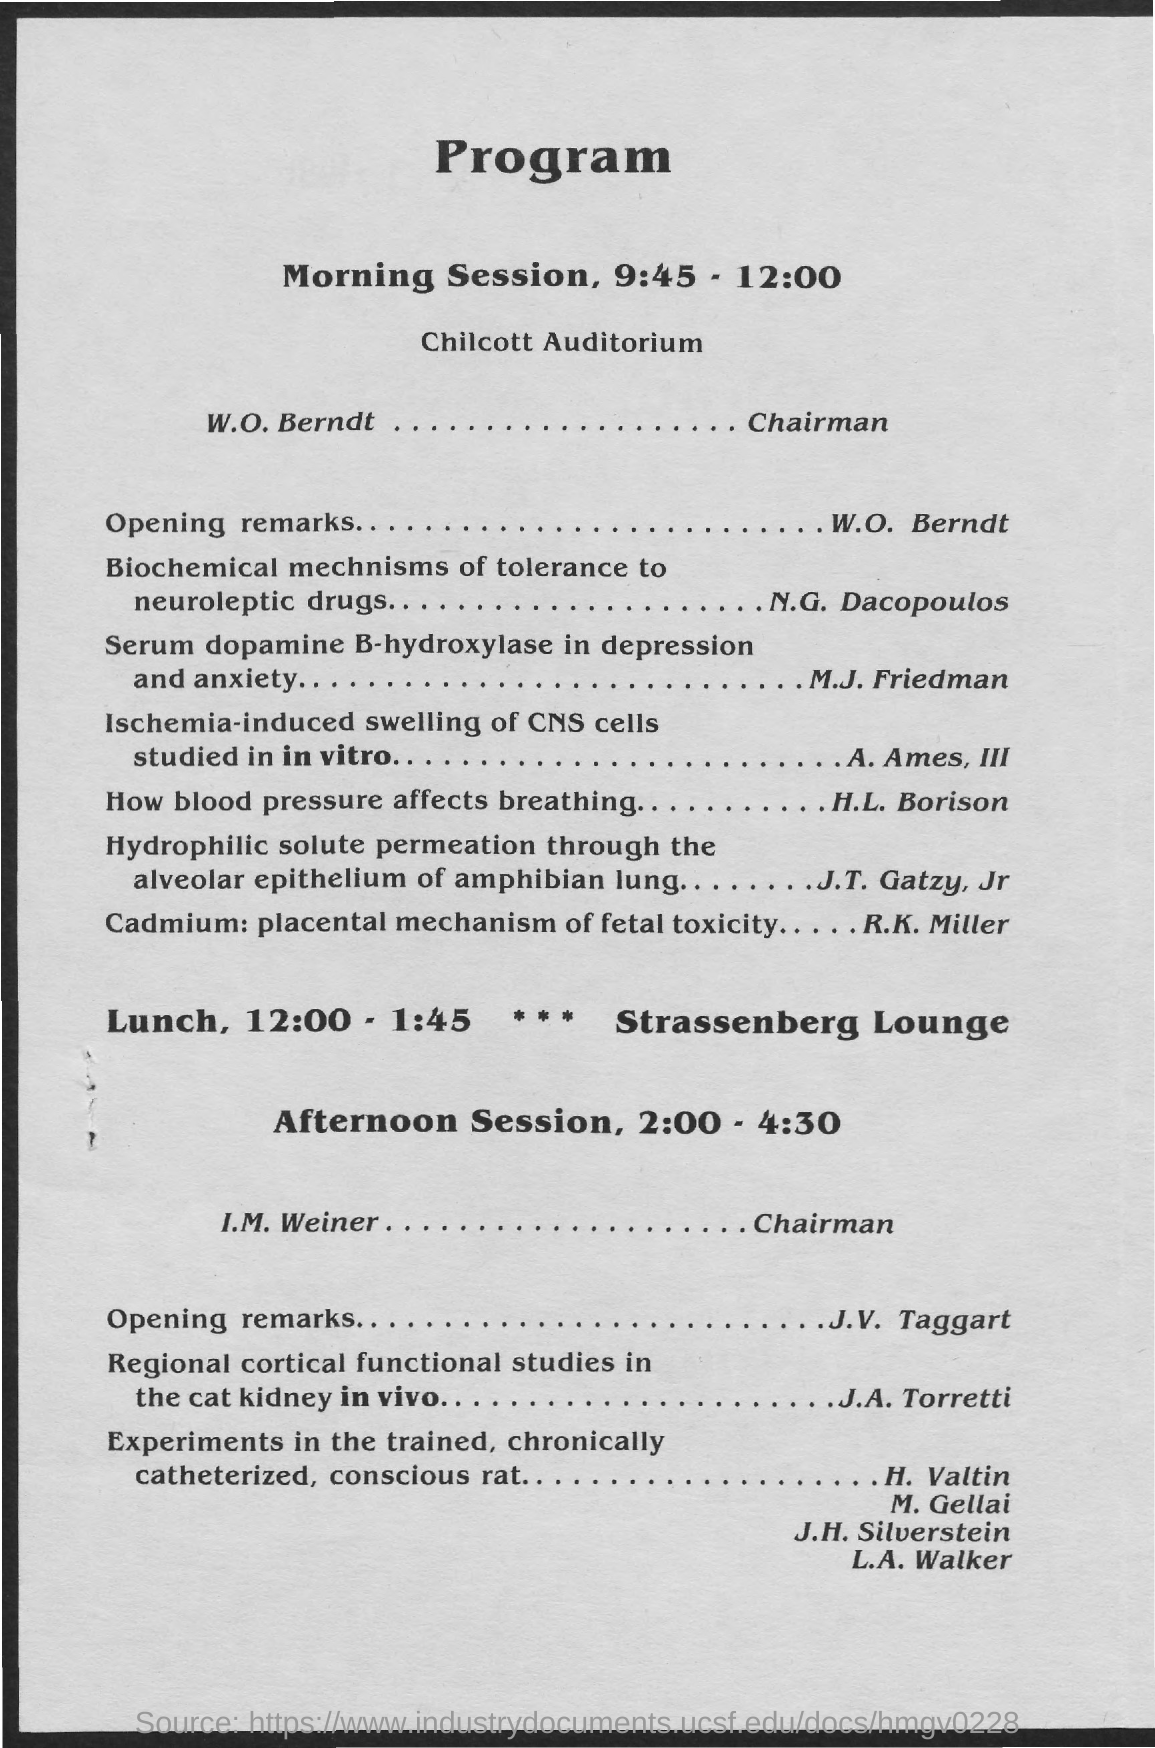Give some essential details in this illustration. The heading of the document is Program. The morning session is scheduled to begin at 9:45 and end at 12:00. 